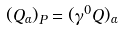<formula> <loc_0><loc_0><loc_500><loc_500>( Q _ { \alpha } ) _ { P } = ( \gamma ^ { 0 } Q ) _ { \alpha }</formula> 